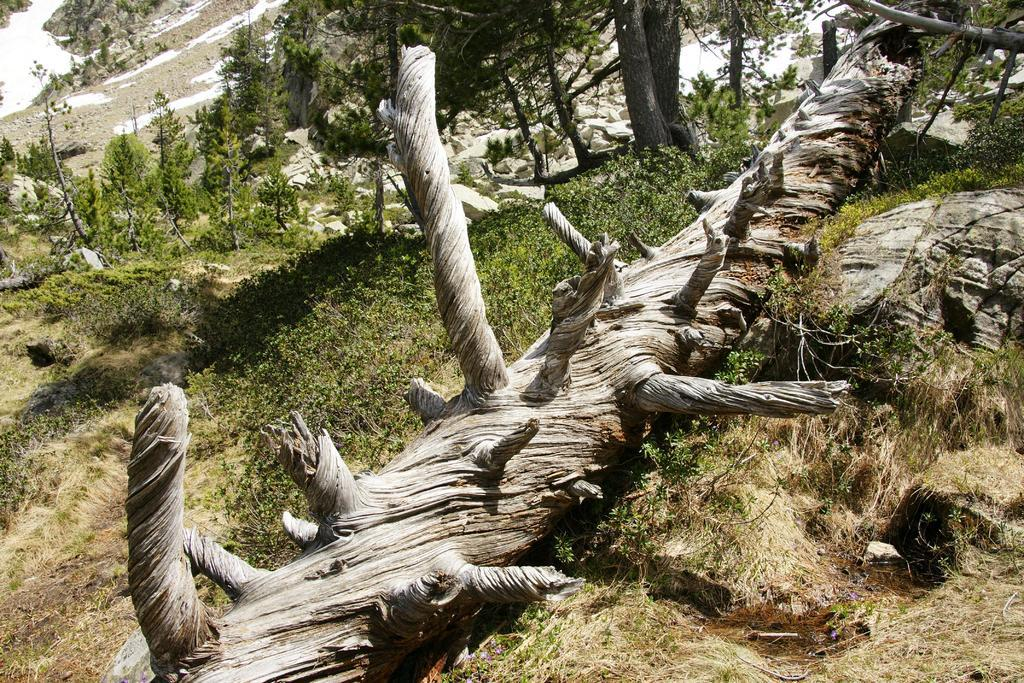What is the main object in the image? There is a log of a tree in the image. What is the terrain like in the image? There is a slope in the image, and trees are present on the slope. What type of surface is visible in the image? Land is visible in the image. Where is the toothbrush located in the image? There is no toothbrush present in the image. What type of soap is being used in the image? There is no soap present in the image. 